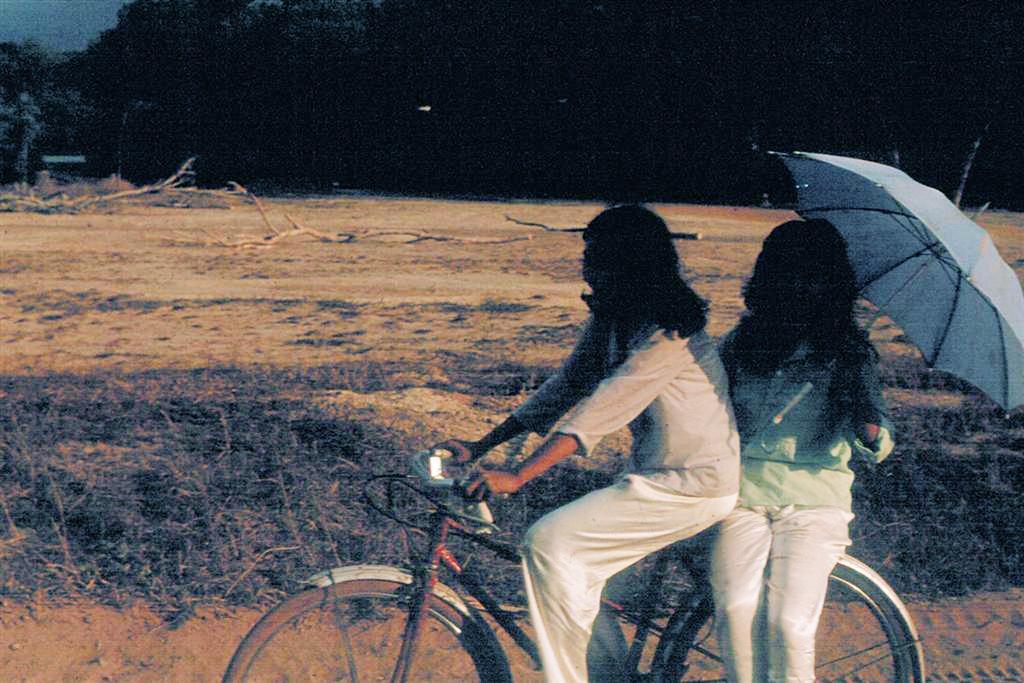How would you summarize this image in a sentence or two? In this image we can see there are two girls riding in a bicycle, one of them is holding an umbrella, back of them there are some branches of trees are on the surface. In the background there are trees. 